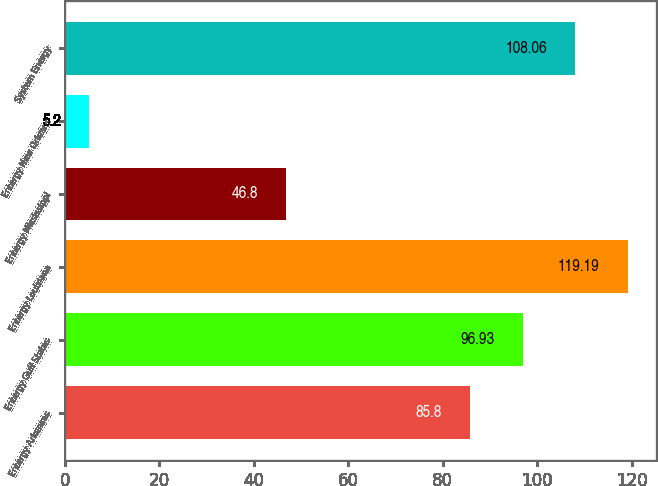<chart> <loc_0><loc_0><loc_500><loc_500><bar_chart><fcel>Entergy Arkansas<fcel>Entergy Gulf States<fcel>Entergy Louisiana<fcel>Entergy Mississippi<fcel>Entergy New Orleans<fcel>System Energy<nl><fcel>85.8<fcel>96.93<fcel>119.19<fcel>46.8<fcel>5.2<fcel>108.06<nl></chart> 